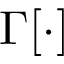<formula> <loc_0><loc_0><loc_500><loc_500>\Gamma [ \cdot ]</formula> 